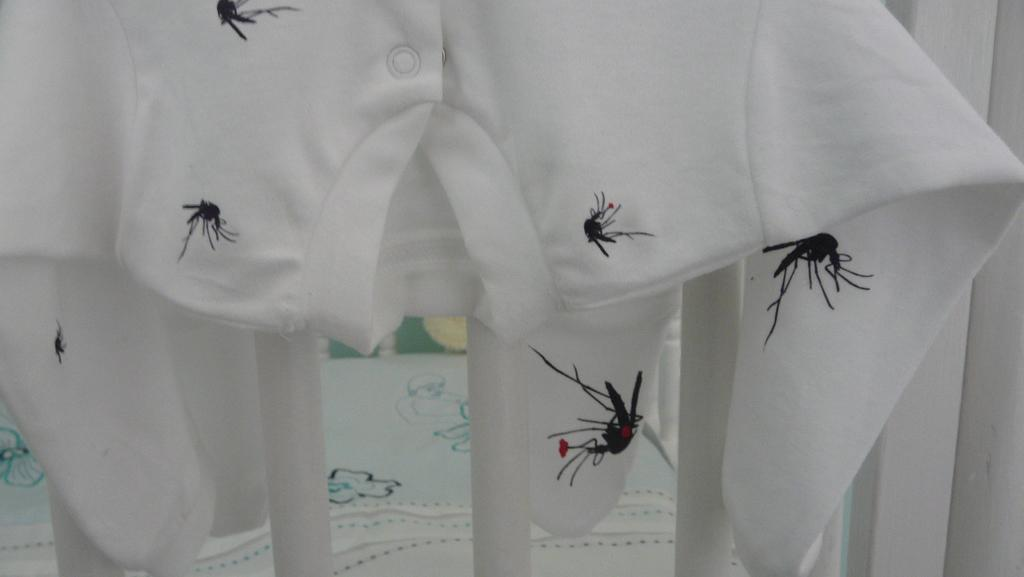What type of clothing is featured in the image? There is a white t-shirt in the image. What design is on the t-shirt? The t-shirt has printings of mosquitoes. What color is the background of the image? The background of the image is white. Where is the bedroom located in the image? There is no bedroom present in the image; it features a white t-shirt with mosquito printings against a white background. What type of activity is happening downtown in the image? There is no downtown or activity happening in the image; it only shows a white t-shirt with mosquito printings against a white background. 